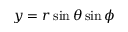<formula> <loc_0><loc_0><loc_500><loc_500>y = r \sin \theta \sin \phi</formula> 